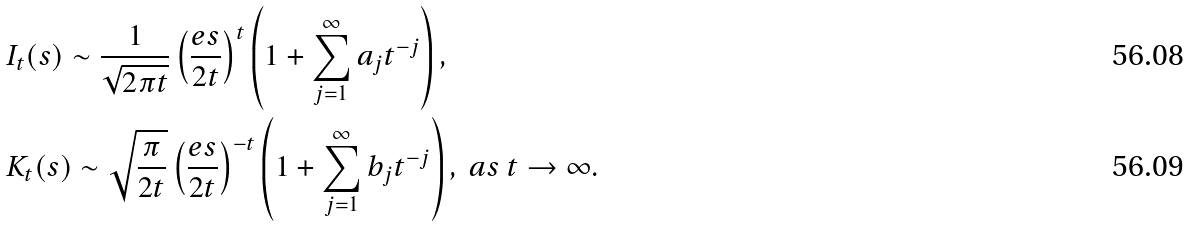<formula> <loc_0><loc_0><loc_500><loc_500>& I _ { t } ( s ) \sim \frac { 1 } { \sqrt { 2 \pi t } } \left ( \frac { e s } { 2 t } \right ) ^ { t } \left ( 1 + \sum _ { j = 1 } ^ { \infty } a _ { j } t ^ { - j } \right ) , \\ & K _ { t } ( s ) \sim \sqrt { \frac { \pi } { 2 t } } \left ( \frac { e s } { 2 t } \right ) ^ { - t } \left ( 1 + \sum _ { j = 1 } ^ { \infty } b _ { j } t ^ { - j } \right ) , \ a s \ t \to \infty .</formula> 